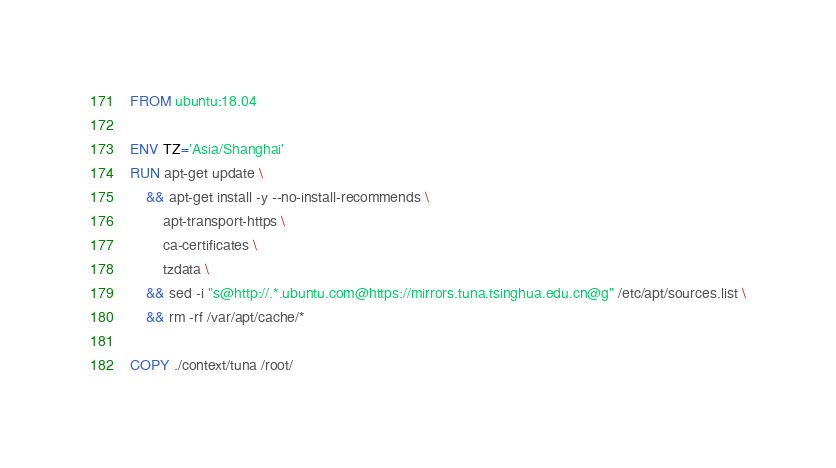<code> <loc_0><loc_0><loc_500><loc_500><_Dockerfile_>FROM ubuntu:18.04

ENV TZ='Asia/Shanghai'
RUN apt-get update \
    && apt-get install -y --no-install-recommends \
        apt-transport-https \
        ca-certificates \
        tzdata \
    && sed -i "s@http://.*.ubuntu.com@https://mirrors.tuna.tsinghua.edu.cn@g" /etc/apt/sources.list \
    && rm -rf /var/apt/cache/*

COPY ./context/tuna /root/
</code> 